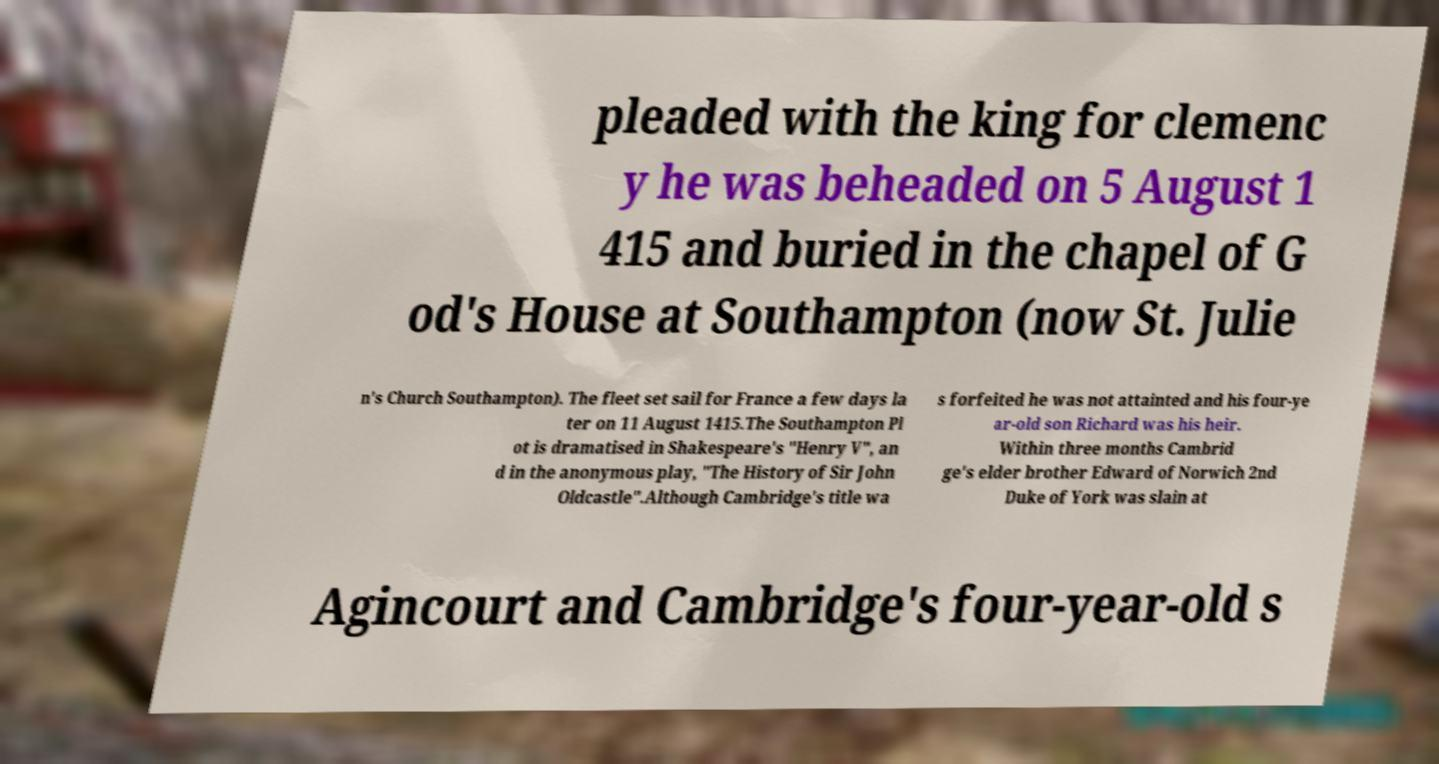I need the written content from this picture converted into text. Can you do that? pleaded with the king for clemenc y he was beheaded on 5 August 1 415 and buried in the chapel of G od's House at Southampton (now St. Julie n's Church Southampton). The fleet set sail for France a few days la ter on 11 August 1415.The Southampton Pl ot is dramatised in Shakespeare's "Henry V", an d in the anonymous play, "The History of Sir John Oldcastle".Although Cambridge's title wa s forfeited he was not attainted and his four-ye ar-old son Richard was his heir. Within three months Cambrid ge's elder brother Edward of Norwich 2nd Duke of York was slain at Agincourt and Cambridge's four-year-old s 